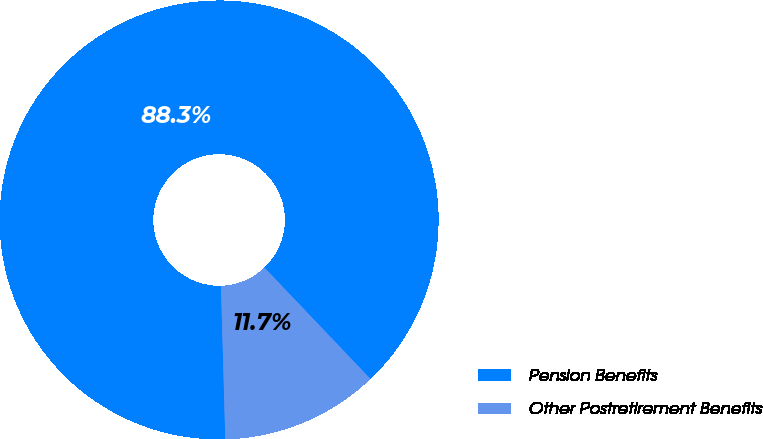<chart> <loc_0><loc_0><loc_500><loc_500><pie_chart><fcel>Pension Benefits<fcel>Other Postretirement Benefits<nl><fcel>88.34%<fcel>11.66%<nl></chart> 